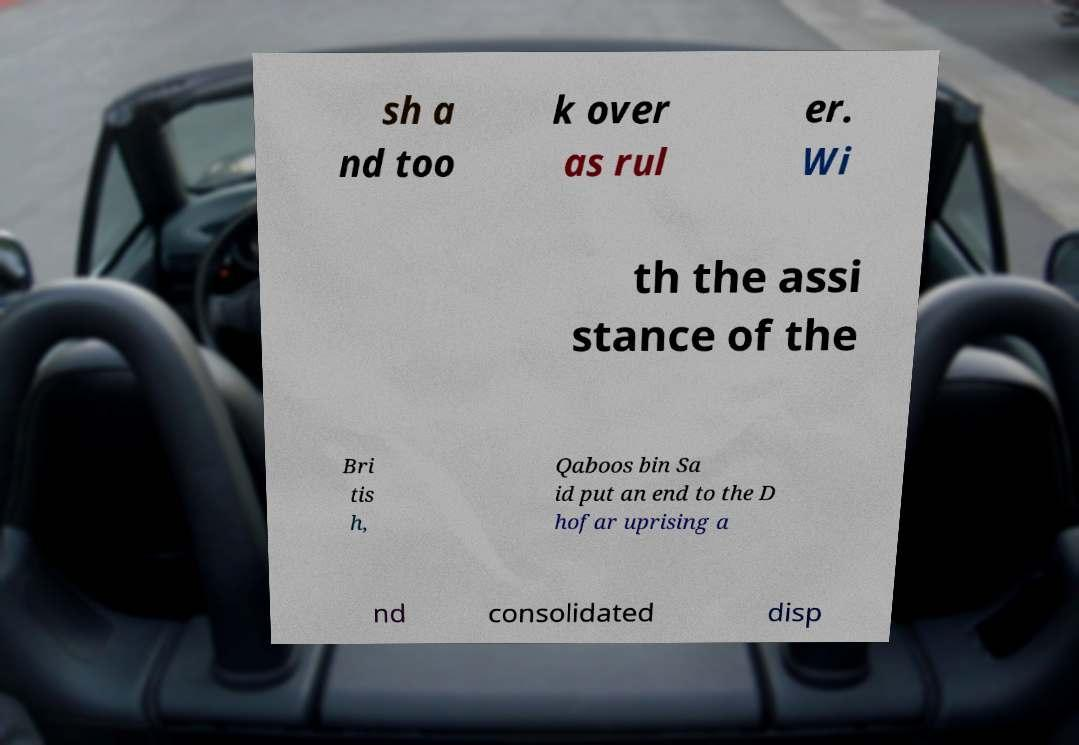Please identify and transcribe the text found in this image. sh a nd too k over as rul er. Wi th the assi stance of the Bri tis h, Qaboos bin Sa id put an end to the D hofar uprising a nd consolidated disp 